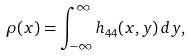<formula> <loc_0><loc_0><loc_500><loc_500>\rho ( x ) = \int _ { - \infty } ^ { \infty } h _ { 4 4 } ( x , y ) \, d y ,</formula> 